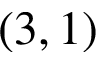Convert formula to latex. <formula><loc_0><loc_0><loc_500><loc_500>( 3 , 1 )</formula> 